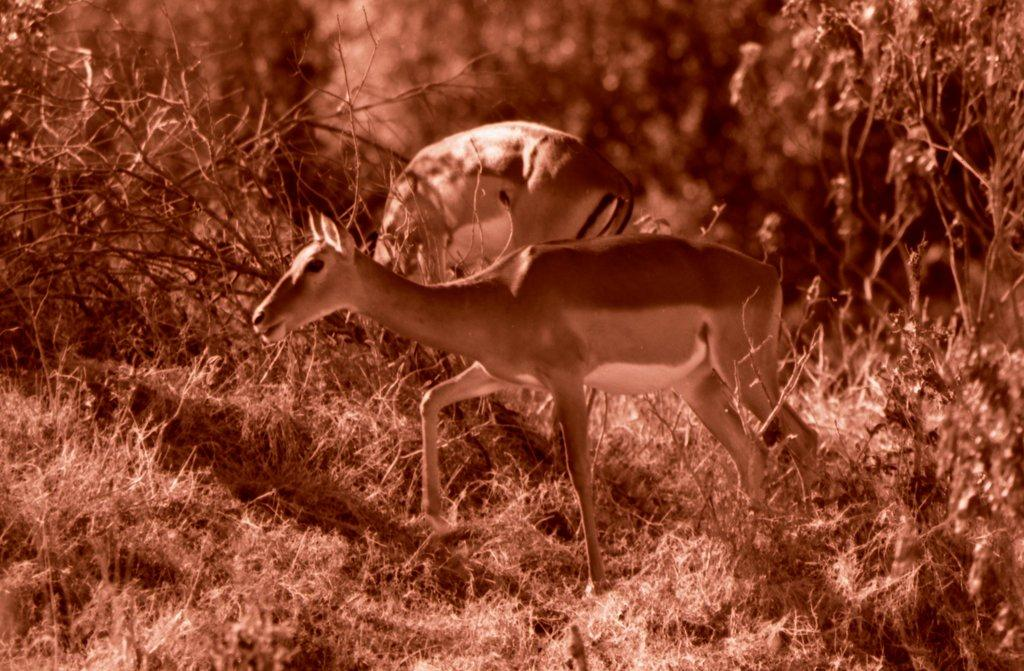What animal can be seen on the ground in the image? There is a deer on the ground in the image. What type of environment is depicted in the background of the image? There are trees visible in the background of the image, suggesting a natural setting. What type of can is visible in the image? There is no can present in the image; it features a deer on the ground and trees in the background. 